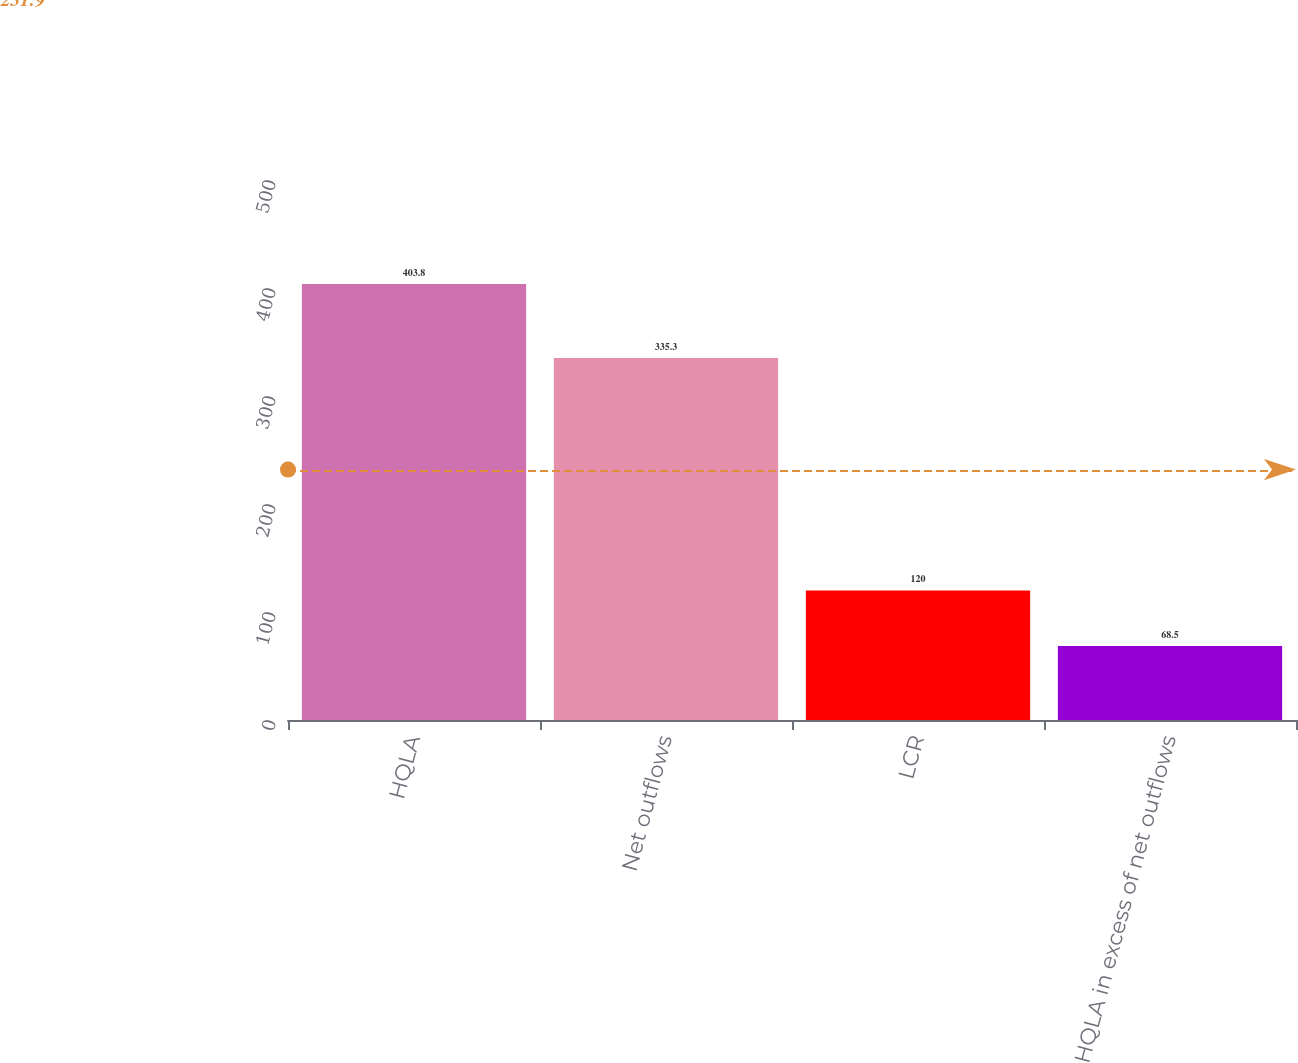Convert chart. <chart><loc_0><loc_0><loc_500><loc_500><bar_chart><fcel>HQLA<fcel>Net outflows<fcel>LCR<fcel>HQLA in excess of net outflows<nl><fcel>403.8<fcel>335.3<fcel>120<fcel>68.5<nl></chart> 